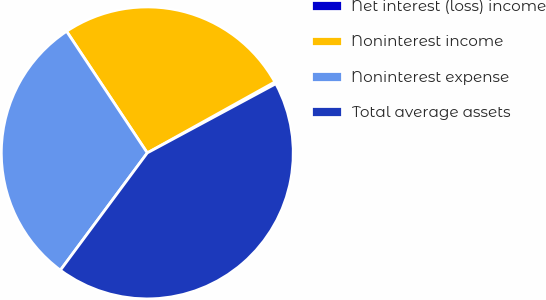Convert chart to OTSL. <chart><loc_0><loc_0><loc_500><loc_500><pie_chart><fcel>Net interest (loss) income<fcel>Noninterest income<fcel>Noninterest expense<fcel>Total average assets<nl><fcel>0.22%<fcel>26.25%<fcel>30.53%<fcel>43.01%<nl></chart> 